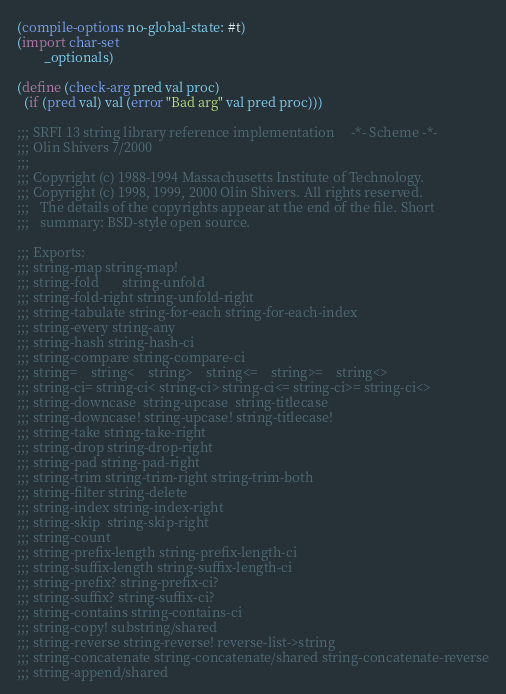Convert code to text. <code><loc_0><loc_0><loc_500><loc_500><_Scheme_>(compile-options no-global-state: #t)
(import char-set
        _optionals)

(define (check-arg pred val proc) 
  (if (pred val) val (error "Bad arg" val pred proc)))

;;; SRFI 13 string library reference implementation		-*- Scheme -*-
;;; Olin Shivers 7/2000
;;;
;;; Copyright (c) 1988-1994 Massachusetts Institute of Technology.
;;; Copyright (c) 1998, 1999, 2000 Olin Shivers. All rights reserved.
;;;   The details of the copyrights appear at the end of the file. Short
;;;   summary: BSD-style open source.

;;; Exports:
;;; string-map string-map!
;;; string-fold       string-unfold
;;; string-fold-right string-unfold-right 
;;; string-tabulate string-for-each string-for-each-index
;;; string-every string-any
;;; string-hash string-hash-ci
;;; string-compare string-compare-ci
;;; string=    string<    string>    string<=    string>=    string<>
;;; string-ci= string-ci< string-ci> string-ci<= string-ci>= string-ci<> 
;;; string-downcase  string-upcase  string-titlecase  
;;; string-downcase! string-upcase! string-titlecase! 
;;; string-take string-take-right
;;; string-drop string-drop-right
;;; string-pad string-pad-right
;;; string-trim string-trim-right string-trim-both
;;; string-filter string-delete
;;; string-index string-index-right 
;;; string-skip  string-skip-right
;;; string-count
;;; string-prefix-length string-prefix-length-ci
;;; string-suffix-length string-suffix-length-ci
;;; string-prefix? string-prefix-ci?
;;; string-suffix? string-suffix-ci?
;;; string-contains string-contains-ci
;;; string-copy! substring/shared
;;; string-reverse string-reverse! reverse-list->string
;;; string-concatenate string-concatenate/shared string-concatenate-reverse
;;; string-append/shared</code> 